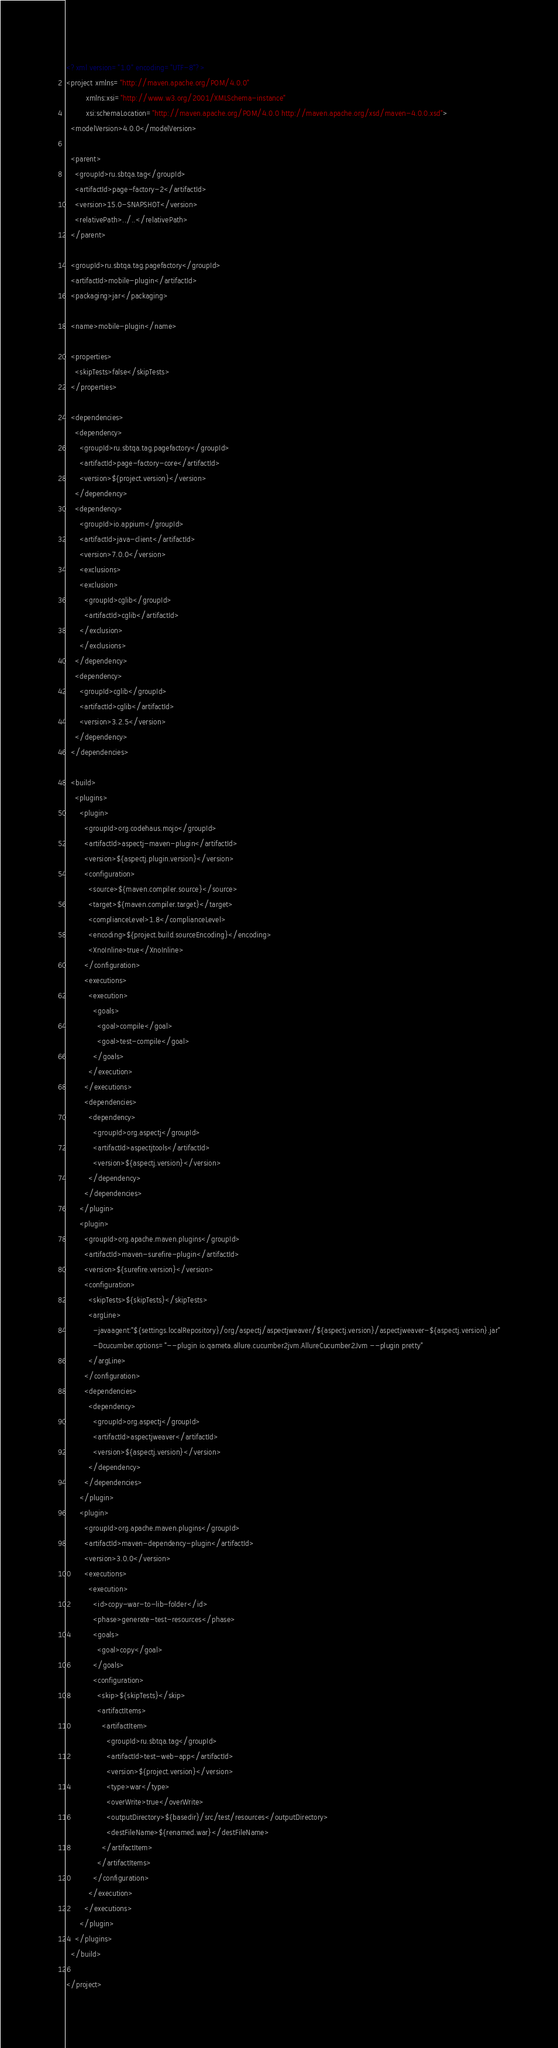Convert code to text. <code><loc_0><loc_0><loc_500><loc_500><_XML_><?xml version="1.0" encoding="UTF-8"?>
<project xmlns="http://maven.apache.org/POM/4.0.0"
         xmlns:xsi="http://www.w3.org/2001/XMLSchema-instance"
         xsi:schemaLocation="http://maven.apache.org/POM/4.0.0 http://maven.apache.org/xsd/maven-4.0.0.xsd">
  <modelVersion>4.0.0</modelVersion>

  <parent>
    <groupId>ru.sbtqa.tag</groupId>
    <artifactId>page-factory-2</artifactId>
    <version>15.0-SNAPSHOT</version>
    <relativePath>../..</relativePath>
  </parent>

  <groupId>ru.sbtqa.tag.pagefactory</groupId>
  <artifactId>mobile-plugin</artifactId>
  <packaging>jar</packaging>

  <name>mobile-plugin</name>

  <properties>
    <skipTests>false</skipTests>
  </properties>

  <dependencies>
    <dependency>
      <groupId>ru.sbtqa.tag.pagefactory</groupId>
      <artifactId>page-factory-core</artifactId>
      <version>${project.version}</version>
    </dependency>
    <dependency>
      <groupId>io.appium</groupId>
      <artifactId>java-client</artifactId>
      <version>7.0.0</version>
      <exclusions>
      <exclusion>
        <groupId>cglib</groupId>
        <artifactId>cglib</artifactId>
      </exclusion>
      </exclusions>
    </dependency>
    <dependency>
      <groupId>cglib</groupId>
      <artifactId>cglib</artifactId>
      <version>3.2.5</version>
    </dependency>
  </dependencies>

  <build>
    <plugins>
      <plugin>
        <groupId>org.codehaus.mojo</groupId>
        <artifactId>aspectj-maven-plugin</artifactId>
        <version>${aspectj.plugin.version}</version>
        <configuration>
          <source>${maven.compiler.source}</source>
          <target>${maven.compiler.target}</target>
          <complianceLevel>1.8</complianceLevel>
          <encoding>${project.build.sourceEncoding}</encoding>
          <XnoInline>true</XnoInline>
        </configuration>
        <executions>
          <execution>
            <goals>
              <goal>compile</goal>
              <goal>test-compile</goal>
            </goals>
          </execution>
        </executions>
        <dependencies>
          <dependency>
            <groupId>org.aspectj</groupId>
            <artifactId>aspectjtools</artifactId>
            <version>${aspectj.version}</version>
          </dependency>
        </dependencies>
      </plugin>
      <plugin>
        <groupId>org.apache.maven.plugins</groupId>
        <artifactId>maven-surefire-plugin</artifactId>
        <version>${surefire.version}</version>
        <configuration>
          <skipTests>${skipTests}</skipTests>
          <argLine>
            -javaagent:"${settings.localRepository}/org/aspectj/aspectjweaver/${aspectj.version}/aspectjweaver-${aspectj.version}.jar"
            -Dcucumber.options="--plugin io.qameta.allure.cucumber2jvm.AllureCucumber2Jvm --plugin pretty"
          </argLine>
        </configuration>
        <dependencies>
          <dependency>
            <groupId>org.aspectj</groupId>
            <artifactId>aspectjweaver</artifactId>
            <version>${aspectj.version}</version>
          </dependency>
        </dependencies>
      </plugin>
      <plugin>
        <groupId>org.apache.maven.plugins</groupId>
        <artifactId>maven-dependency-plugin</artifactId>
        <version>3.0.0</version>
        <executions>
          <execution>
            <id>copy-war-to-lib-folder</id>
            <phase>generate-test-resources</phase>
            <goals>
              <goal>copy</goal>
            </goals>
            <configuration>
              <skip>${skipTests}</skip>
              <artifactItems>
                <artifactItem>
                  <groupId>ru.sbtqa.tag</groupId>
                  <artifactId>test-web-app</artifactId>
                  <version>${project.version}</version>
                  <type>war</type>
                  <overWrite>true</overWrite>
                  <outputDirectory>${basedir}/src/test/resources</outputDirectory>
                  <destFileName>${renamed.war}</destFileName>
                </artifactItem>
              </artifactItems>
            </configuration>
          </execution>
        </executions>
      </plugin>
    </plugins>
  </build>

</project>
</code> 